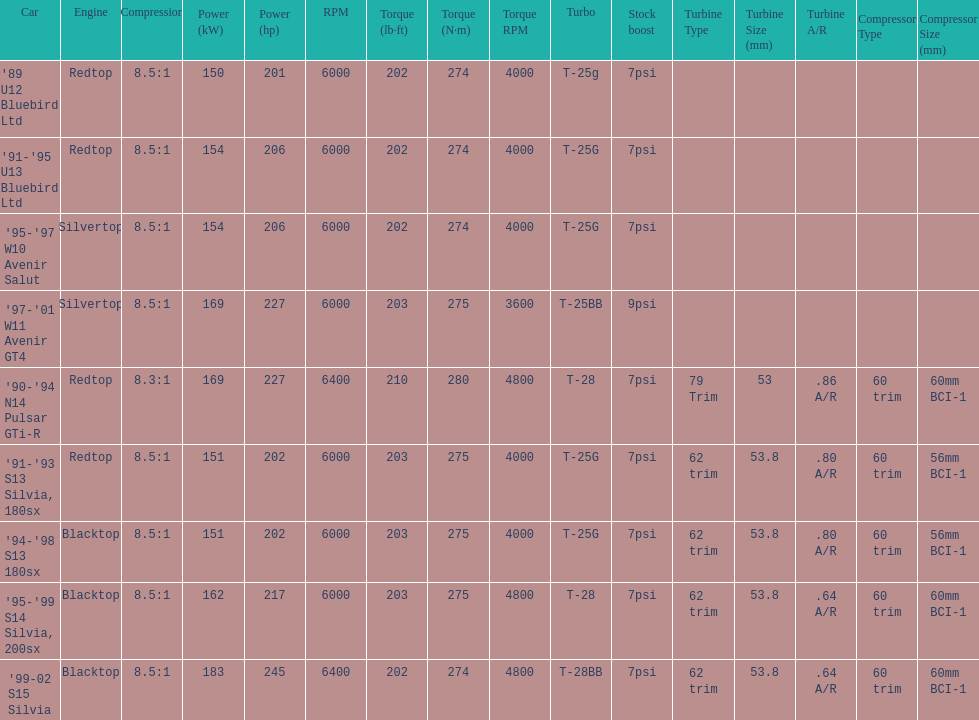Could you parse the entire table as a dict? {'header': ['Car', 'Engine', 'Compression', 'Power (kW)', 'Power (hp)', 'RPM', 'Torque (lb·ft)', 'Torque (N·m)', 'Torque RPM', 'Turbo', 'Stock boost', 'Turbine Type', 'Turbine Size (mm)', 'Turbine A/R', 'Compressor Type', 'Compressor Size (mm)'], 'rows': [["'89 U12 Bluebird Ltd", 'Redtop', '8.5:1', '150', '201', '6000', '202', '274', '4000', 'T-25g', '7psi', '', '', '', '', ''], ["'91-'95 U13 Bluebird Ltd", 'Redtop', '8.5:1', '154', '206', '6000', '202', '274', '4000', 'T-25G', '7psi', '', '', '', '', ''], ["'95-'97 W10 Avenir Salut", 'Silvertop', '8.5:1', '154', '206', '6000', '202', '274', '4000', 'T-25G', '7psi', '', '', '', '', ''], ["'97-'01 W11 Avenir GT4", 'Silvertop', '8.5:1', '169', '227', '6000', '203', '275', '3600', 'T-25BB', '9psi', '', '', '', '', ''], ["'90-'94 N14 Pulsar GTi-R", 'Redtop', '8.3:1', '169', '227', '6400', '210', '280', '4800', 'T-28', '7psi', '79 Trim', '53', '.86 A/R', '60 trim', '60mm BCI-1'], ["'91-'93 S13 Silvia, 180sx", 'Redtop', '8.5:1', '151', '202', '6000', '203', '275', '4000', 'T-25G', '7psi', '62 trim', '53.8', '.80 A/R', '60 trim', '56mm BCI-1'], ["'94-'98 S13 180sx", 'Blacktop', '8.5:1', '151', '202', '6000', '203', '275', '4000', 'T-25G', '7psi', '62 trim', '53.8', '.80 A/R', '60 trim', '56mm BCI-1'], ["'95-'99 S14 Silvia, 200sx", 'Blacktop', '8.5:1', '162', '217', '6000', '203', '275', '4800', 'T-28', '7psi', '62 trim', '53.8', '.64 A/R', '60 trim', '60mm BCI-1'], ["'99-02 S15 Silvia", 'Blacktop', '8.5:1', '183', '245', '6400', '202', '274', '4800', 'T-28BB', '7psi', '62 trim', '53.8', '.64 A/R', '60 trim', '60mm BCI-1']]} How many models used the redtop engine? 4. 